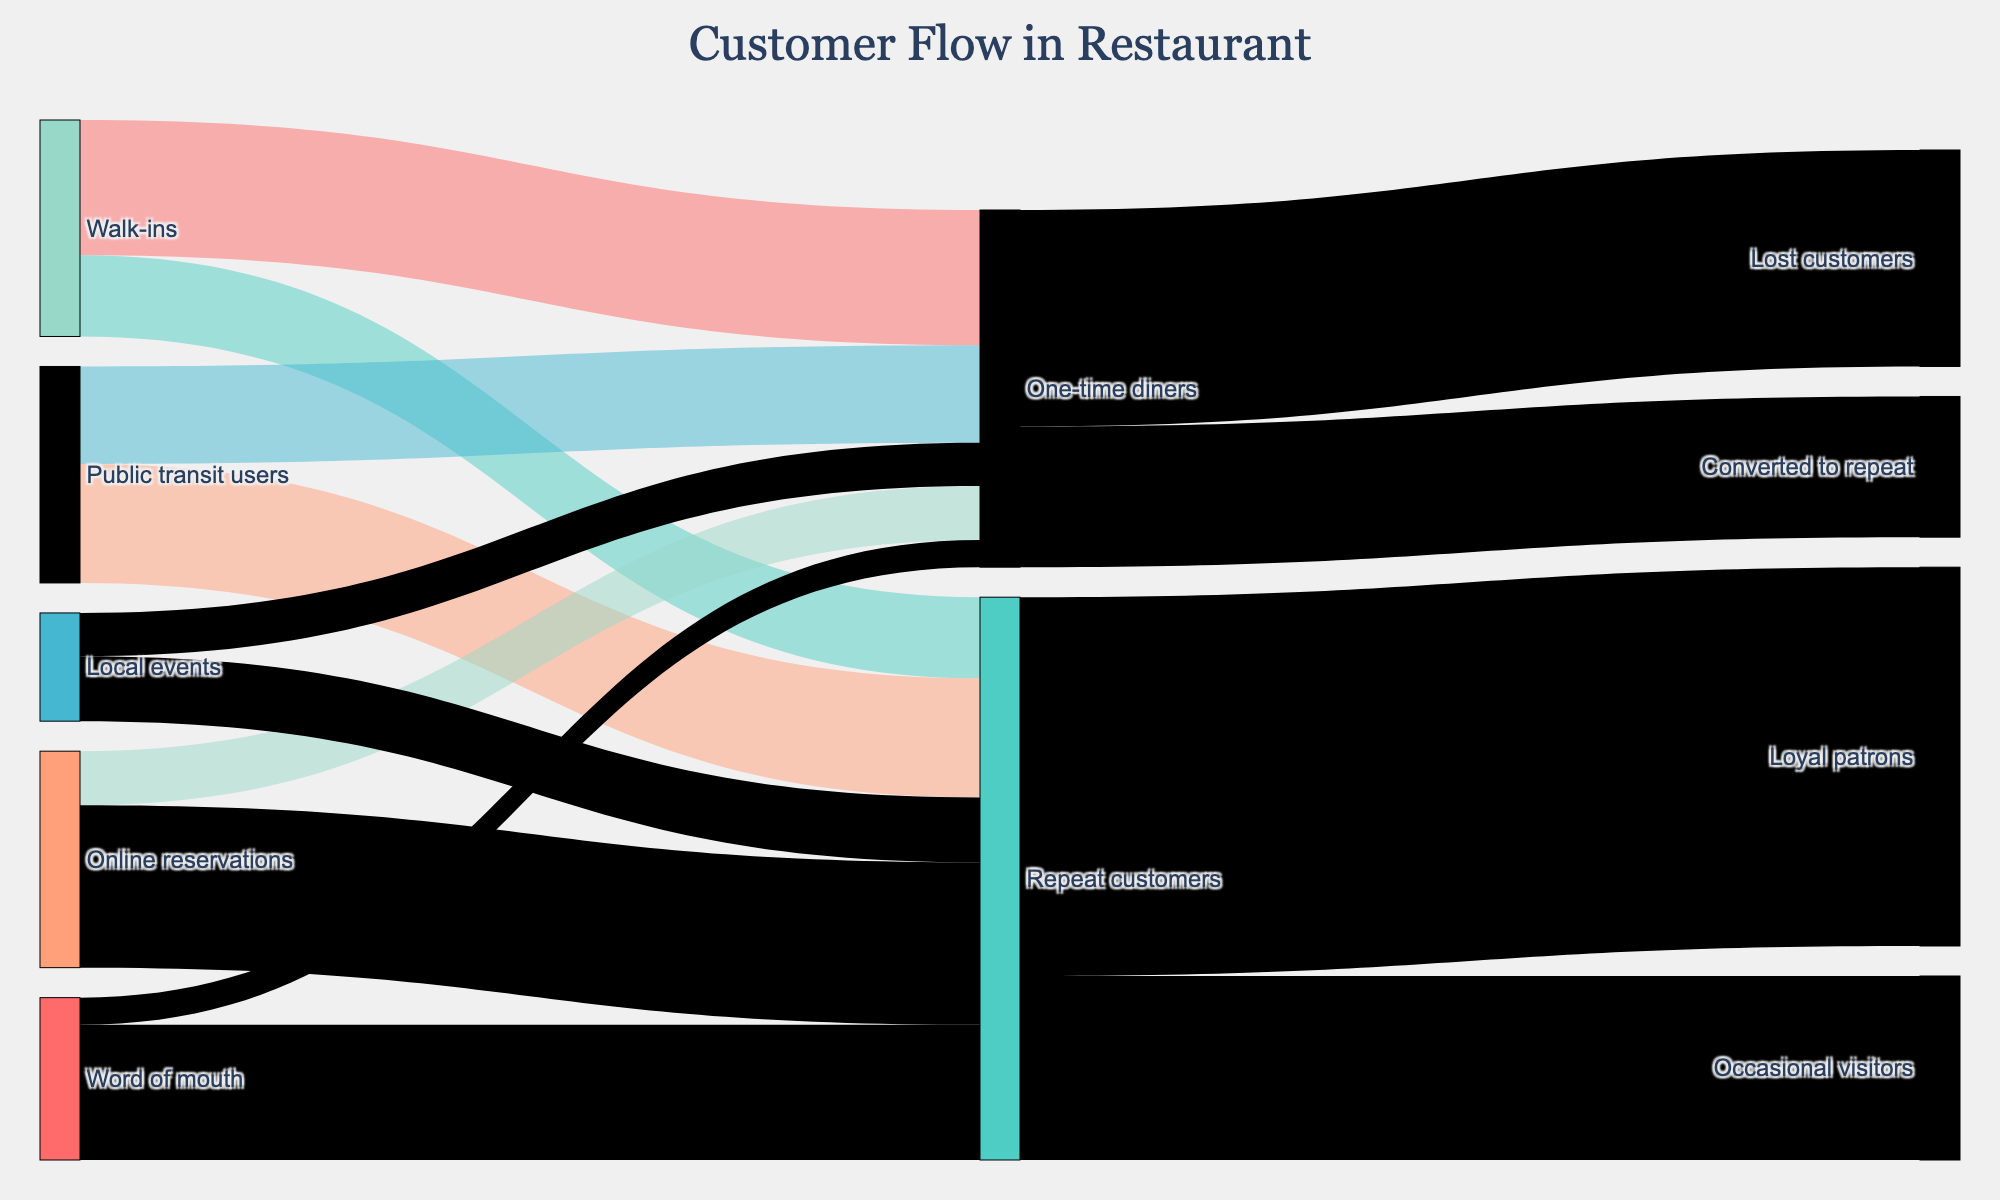what is the title of the Sankey Diagram? The title is always displayed at the top of the figure for context about what the diagram is illustrating. The diagram is titled "Customer Flow in Restaurant".
Answer: Customer Flow in Restaurant Which acquisition channel has the highest number of repeat customers? The Sankey diagram shows the flow from different acquisition channels to repeat customers. The "Online reservations" channel flows to repeat customers with a value of 300, which is higher than the other channels.
Answer: Online reservations How many people from public transit users end up as repeat customers? You can trace the flow from "Public transit users" to "Repeat customers" in the diagram, which is represented by a value of 220.
Answer: 220 What is the total number of one-time diners? To find the total number of one-time diners, add the values flowing into "One-time diners": 250 (Walk-ins) + 180 (Public transit users) + 100 (Online reservations) + 80 (Local events) + 50 (Word of mouth) = 660.
Answer: 660 What proportion of word of mouth customers become repeat customers? To find the proportion, divide the number of word of mouth customers that become repeat customers (250) by the total word of mouth customers (50 + 250). The proportion is 250 / (50 + 250) = 250 / 300 = 0.833 or 83.3%.
Answer: 83.3% Which segment has more people, loyal patrons or occasional visitors? The diagram shows the flow from repeat customers to either loyal patrons or occasional visitors. The flows are 700 for loyal patrons and 340 for occasional visitors. 700 > 340, so loyal patrons are more.
Answer: Loyal patrons What is the combined number of customers from local events and online reservations who become repeat customers? The values for local events and online reservations becoming repeat customers are 120 and 300, respectively. Add them together: 120 + 300 = 420.
Answer: 420 How many total diners end up being lost customers? The only flow leading into lost customers comes from one-time diners, with a value of 400. So, the total number of lost customers is 400.
Answer: 400 What is the difference between the number of public transit users converting to repeat customers and those who are one-time diners? The value for public transit users becoming repeat customers is 220 and for one-time diners is 180. The difference is 220 - 180 = 40.
Answer: 40 